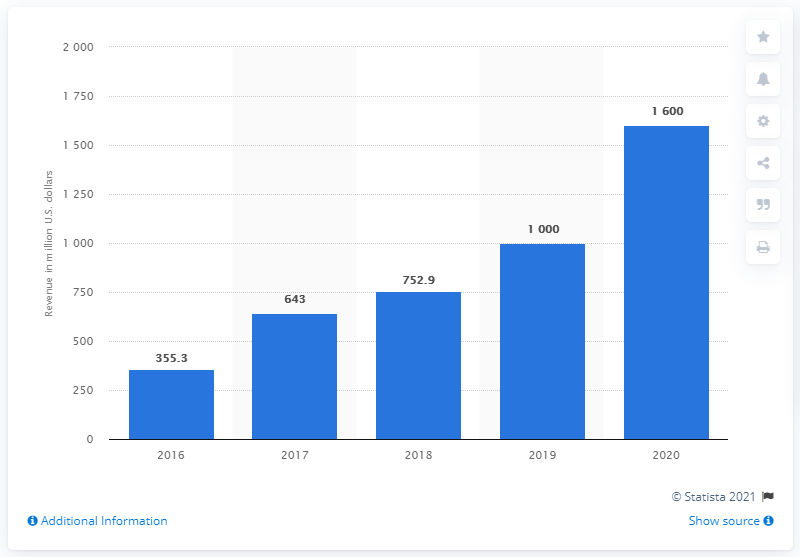Can you estimate the percentage growth in revenue from 2019 to 2020? The percentage growth from 2019 to 2020 appears to be about 60%, expanding from around $1,000 million in 2019 to $1,600 million in the following year. 